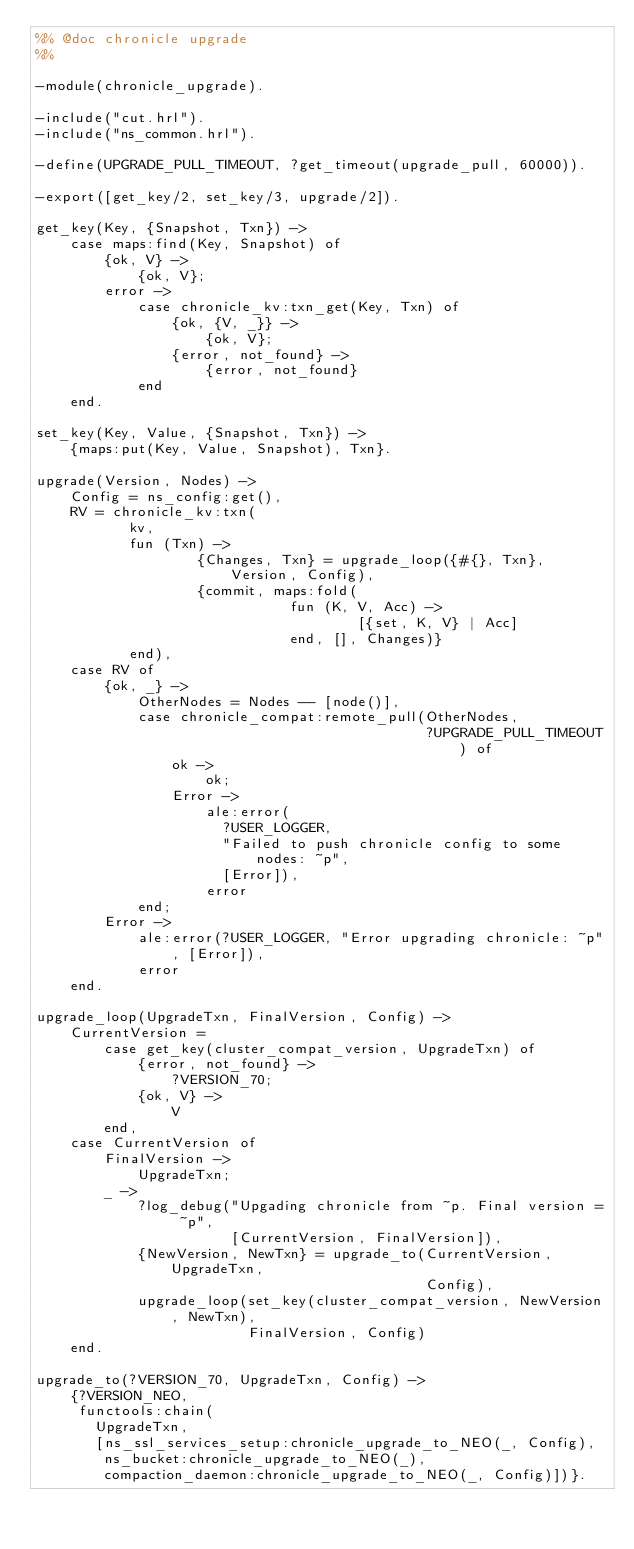Convert code to text. <code><loc_0><loc_0><loc_500><loc_500><_Erlang_>%% @doc chronicle upgrade
%%

-module(chronicle_upgrade).

-include("cut.hrl").
-include("ns_common.hrl").

-define(UPGRADE_PULL_TIMEOUT, ?get_timeout(upgrade_pull, 60000)).

-export([get_key/2, set_key/3, upgrade/2]).

get_key(Key, {Snapshot, Txn}) ->
    case maps:find(Key, Snapshot) of
        {ok, V} ->
            {ok, V};
        error ->
            case chronicle_kv:txn_get(Key, Txn) of
                {ok, {V, _}} ->
                    {ok, V};
                {error, not_found} ->
                    {error, not_found}
            end
    end.

set_key(Key, Value, {Snapshot, Txn}) ->
    {maps:put(Key, Value, Snapshot), Txn}.

upgrade(Version, Nodes) ->
    Config = ns_config:get(),
    RV = chronicle_kv:txn(
           kv,
           fun (Txn) ->
                   {Changes, Txn} = upgrade_loop({#{}, Txn}, Version, Config),
                   {commit, maps:fold(
                              fun (K, V, Acc) ->
                                      [{set, K, V} | Acc]
                              end, [], Changes)}
           end),
    case RV of
        {ok, _} ->
            OtherNodes = Nodes -- [node()],
            case chronicle_compat:remote_pull(OtherNodes,
                                              ?UPGRADE_PULL_TIMEOUT) of
                ok ->
                    ok;
                Error ->
                    ale:error(
                      ?USER_LOGGER,
                      "Failed to push chronicle config to some nodes: ~p",
                      [Error]),
                    error
            end;
        Error ->
            ale:error(?USER_LOGGER, "Error upgrading chronicle: ~p", [Error]),
            error
    end.

upgrade_loop(UpgradeTxn, FinalVersion, Config) ->
    CurrentVersion =
        case get_key(cluster_compat_version, UpgradeTxn) of
            {error, not_found} ->
                ?VERSION_70;
            {ok, V} ->
                V
        end,
    case CurrentVersion of
        FinalVersion ->
            UpgradeTxn;
        _ ->
            ?log_debug("Upgading chronicle from ~p. Final version = ~p",
                       [CurrentVersion, FinalVersion]),
            {NewVersion, NewTxn} = upgrade_to(CurrentVersion, UpgradeTxn,
                                              Config),
            upgrade_loop(set_key(cluster_compat_version, NewVersion, NewTxn),
                         FinalVersion, Config)
    end.

upgrade_to(?VERSION_70, UpgradeTxn, Config) ->
    {?VERSION_NEO,
     functools:chain(
       UpgradeTxn,
       [ns_ssl_services_setup:chronicle_upgrade_to_NEO(_, Config),
        ns_bucket:chronicle_upgrade_to_NEO(_),
        compaction_daemon:chronicle_upgrade_to_NEO(_, Config)])}.
</code> 